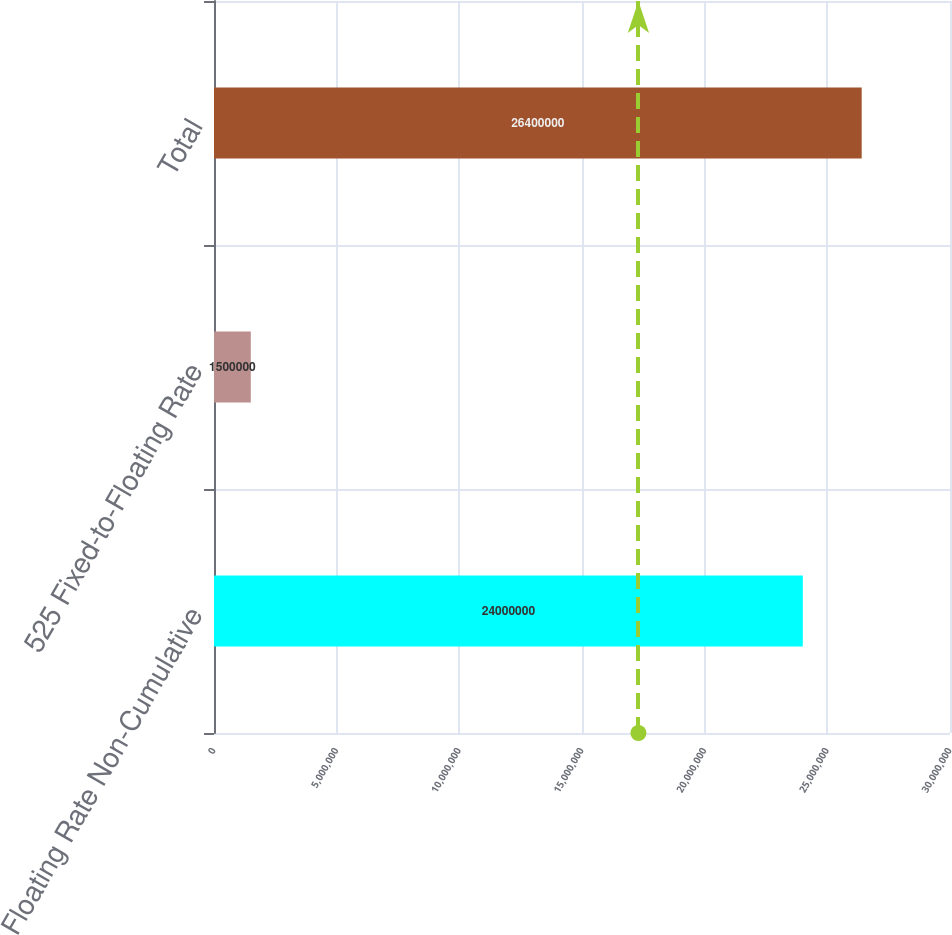Convert chart to OTSL. <chart><loc_0><loc_0><loc_500><loc_500><bar_chart><fcel>Floating Rate Non-Cumulative<fcel>525 Fixed-to-Floating Rate<fcel>Total<nl><fcel>2.4e+07<fcel>1.5e+06<fcel>2.64e+07<nl></chart> 